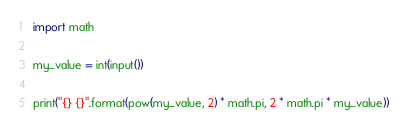<code> <loc_0><loc_0><loc_500><loc_500><_Python_>import math

my_value = int(input())

print("{} {}".format(pow(my_value, 2) * math.pi, 2 * math.pi * my_value))</code> 